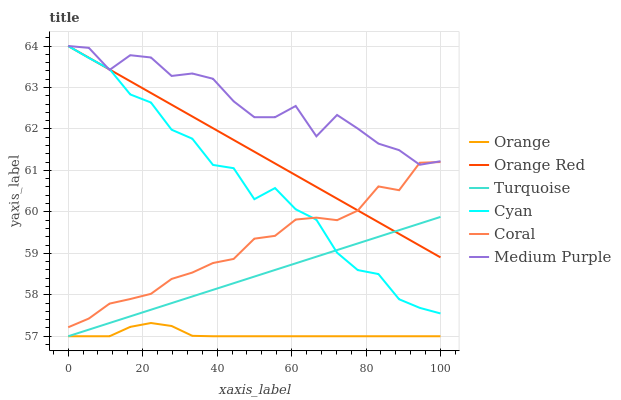Does Orange have the minimum area under the curve?
Answer yes or no. Yes. Does Medium Purple have the maximum area under the curve?
Answer yes or no. Yes. Does Coral have the minimum area under the curve?
Answer yes or no. No. Does Coral have the maximum area under the curve?
Answer yes or no. No. Is Turquoise the smoothest?
Answer yes or no. Yes. Is Medium Purple the roughest?
Answer yes or no. Yes. Is Coral the smoothest?
Answer yes or no. No. Is Coral the roughest?
Answer yes or no. No. Does Turquoise have the lowest value?
Answer yes or no. Yes. Does Coral have the lowest value?
Answer yes or no. No. Does Orange Red have the highest value?
Answer yes or no. Yes. Does Coral have the highest value?
Answer yes or no. No. Is Turquoise less than Medium Purple?
Answer yes or no. Yes. Is Medium Purple greater than Turquoise?
Answer yes or no. Yes. Does Medium Purple intersect Orange Red?
Answer yes or no. Yes. Is Medium Purple less than Orange Red?
Answer yes or no. No. Is Medium Purple greater than Orange Red?
Answer yes or no. No. Does Turquoise intersect Medium Purple?
Answer yes or no. No. 